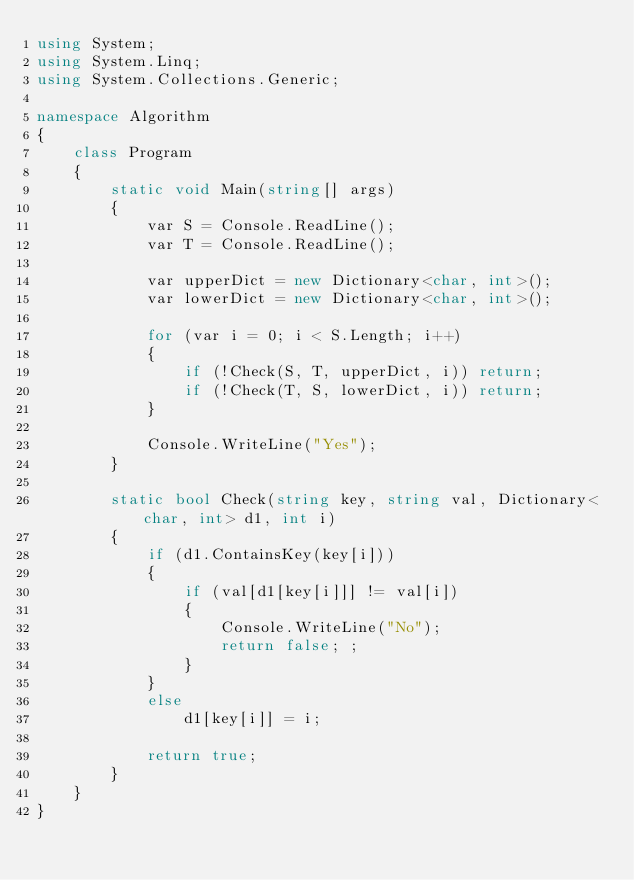<code> <loc_0><loc_0><loc_500><loc_500><_C#_>using System;
using System.Linq;
using System.Collections.Generic;

namespace Algorithm
{
    class Program
    {
        static void Main(string[] args)
        {
            var S = Console.ReadLine();
            var T = Console.ReadLine();

            var upperDict = new Dictionary<char, int>();
            var lowerDict = new Dictionary<char, int>();

            for (var i = 0; i < S.Length; i++)
            {
                if (!Check(S, T, upperDict, i)) return;
                if (!Check(T, S, lowerDict, i)) return;
            }

            Console.WriteLine("Yes");
        }

        static bool Check(string key, string val, Dictionary<char, int> d1, int i)
        {
            if (d1.ContainsKey(key[i]))
            {
                if (val[d1[key[i]]] != val[i])
                {
                    Console.WriteLine("No");
                    return false; ;
                }
            }
            else
                d1[key[i]] = i;

            return true;
        }
    }
}
</code> 